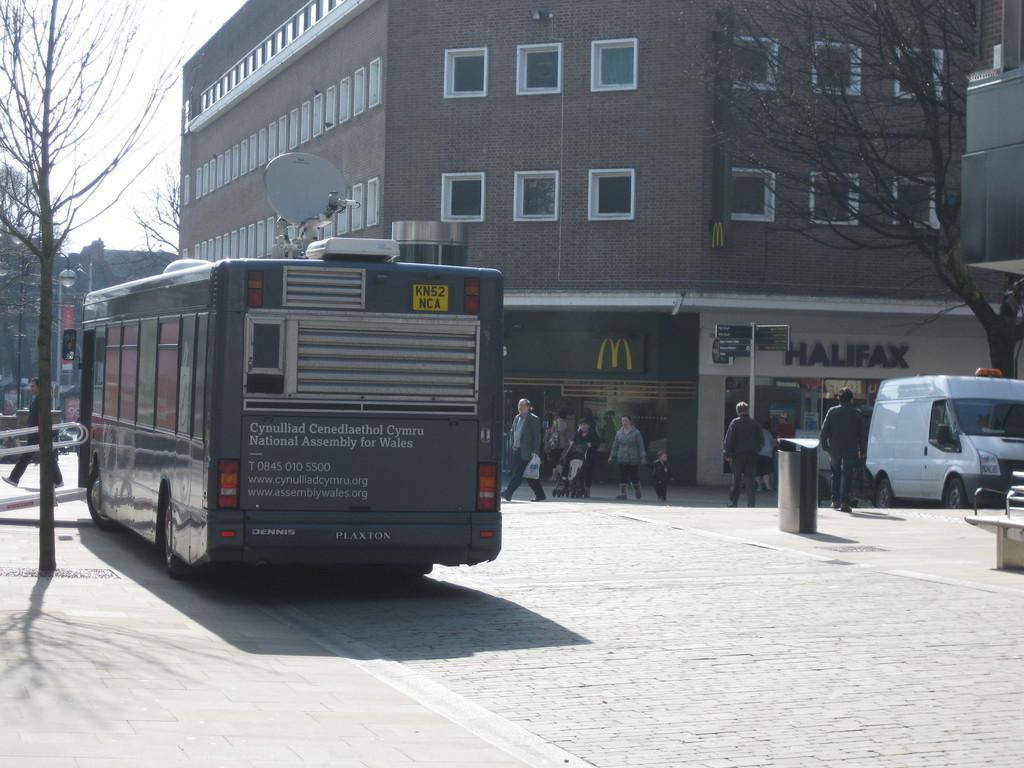Can you describe this image briefly? In this image we can see a bus on the road. There are people walking. In the background of the image there are buildings. To the right side of the image there is a tree. To the left side of the image there is another tree. At the top of the image there is sky. 